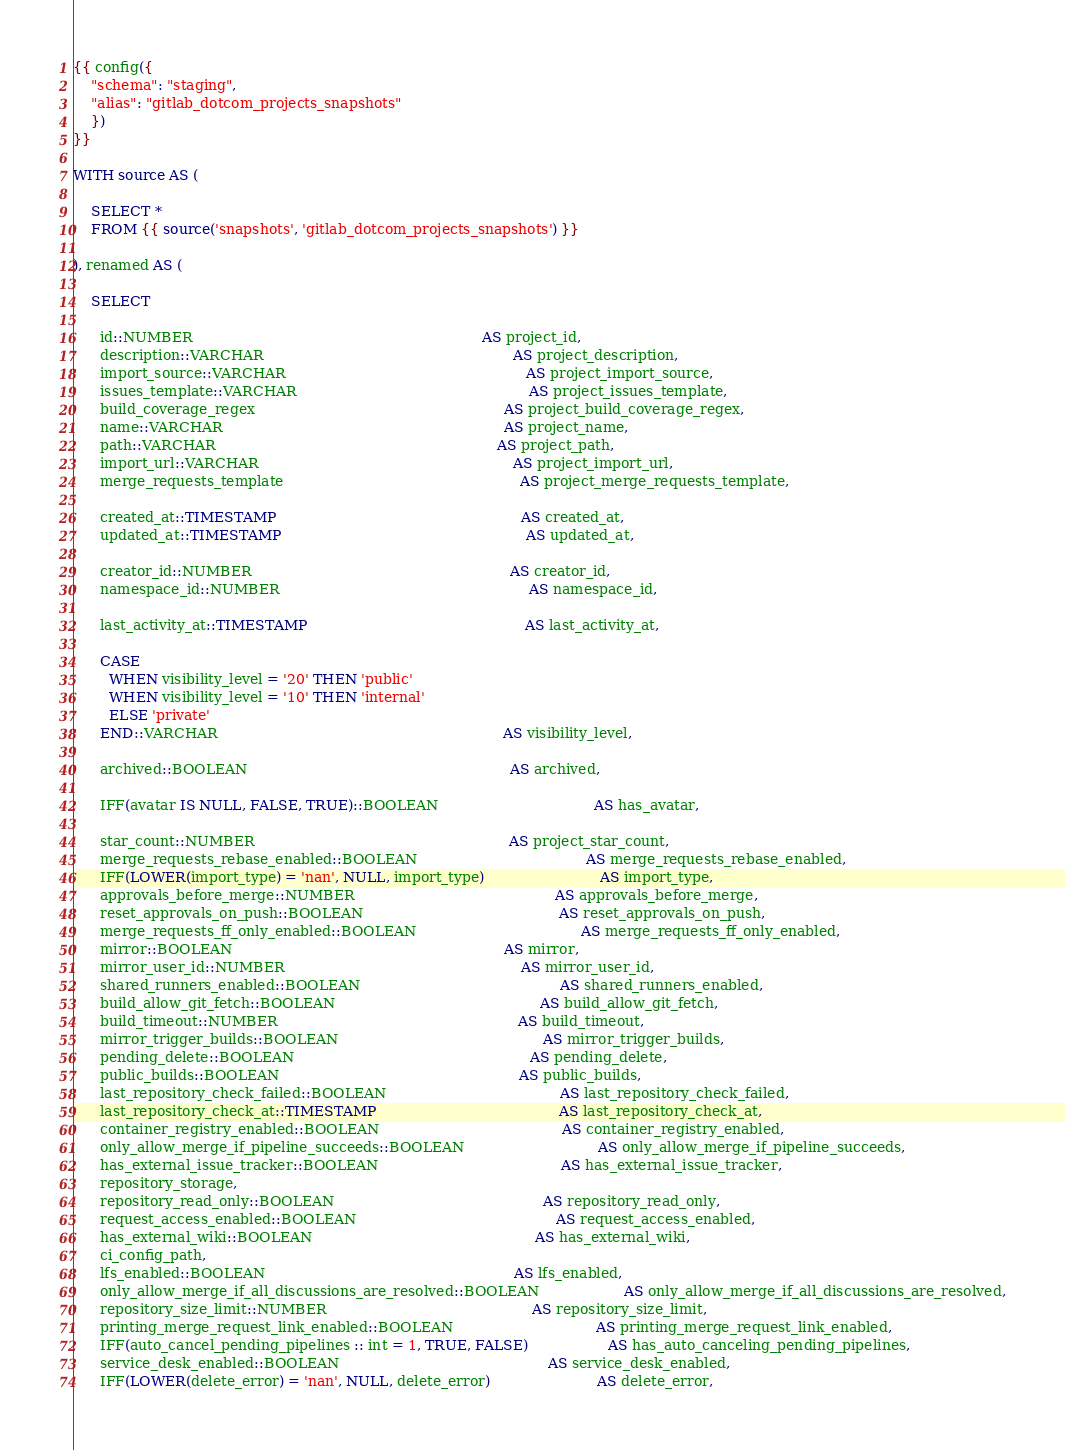Convert code to text. <code><loc_0><loc_0><loc_500><loc_500><_SQL_>{{ config({
    "schema": "staging",
    "alias": "gitlab_dotcom_projects_snapshots"
    })
}}

WITH source AS (

    SELECT *
    FROM {{ source('snapshots', 'gitlab_dotcom_projects_snapshots') }}

), renamed AS (

    SELECT

      id::NUMBER                                                                 AS project_id,
      description::VARCHAR                                                        AS project_description,
      import_source::VARCHAR                                                      AS project_import_source,
      issues_template::VARCHAR                                                    AS project_issues_template,
      build_coverage_regex                                                        AS project_build_coverage_regex,      
      name::VARCHAR                                                               AS project_name,
      path::VARCHAR                                                               AS project_path,
      import_url::VARCHAR                                                         AS project_import_url,
      merge_requests_template                                                     AS project_merge_requests_template,

      created_at::TIMESTAMP                                                       AS created_at,
      updated_at::TIMESTAMP                                                       AS updated_at,

      creator_id::NUMBER                                                          AS creator_id,
      namespace_id::NUMBER                                                        AS namespace_id,

      last_activity_at::TIMESTAMP                                                 AS last_activity_at,

      CASE
        WHEN visibility_level = '20' THEN 'public'
        WHEN visibility_level = '10' THEN 'internal'
        ELSE 'private'
      END::VARCHAR                                                                AS visibility_level,

      archived::BOOLEAN                                                           AS archived,

      IFF(avatar IS NULL, FALSE, TRUE)::BOOLEAN                                   AS has_avatar,

      star_count::NUMBER                                                         AS project_star_count,
      merge_requests_rebase_enabled::BOOLEAN                                      AS merge_requests_rebase_enabled,
      IFF(LOWER(import_type) = 'nan', NULL, import_type)                          AS import_type,
      approvals_before_merge::NUMBER                                             AS approvals_before_merge,
      reset_approvals_on_push::BOOLEAN                                            AS reset_approvals_on_push,
      merge_requests_ff_only_enabled::BOOLEAN                                     AS merge_requests_ff_only_enabled,
      mirror::BOOLEAN                                                             AS mirror,
      mirror_user_id::NUMBER                                                     AS mirror_user_id,
      shared_runners_enabled::BOOLEAN                                             AS shared_runners_enabled,
      build_allow_git_fetch::BOOLEAN                                              AS build_allow_git_fetch,
      build_timeout::NUMBER                                                      AS build_timeout,
      mirror_trigger_builds::BOOLEAN                                              AS mirror_trigger_builds,
      pending_delete::BOOLEAN                                                     AS pending_delete,
      public_builds::BOOLEAN                                                      AS public_builds,
      last_repository_check_failed::BOOLEAN                                       AS last_repository_check_failed,
      last_repository_check_at::TIMESTAMP                                         AS last_repository_check_at,
      container_registry_enabled::BOOLEAN                                         AS container_registry_enabled,
      only_allow_merge_if_pipeline_succeeds::BOOLEAN                              AS only_allow_merge_if_pipeline_succeeds,
      has_external_issue_tracker::BOOLEAN                                         AS has_external_issue_tracker,
      repository_storage,
      repository_read_only::BOOLEAN                                               AS repository_read_only,
      request_access_enabled::BOOLEAN                                             AS request_access_enabled,
      has_external_wiki::BOOLEAN                                                  AS has_external_wiki,
      ci_config_path,
      lfs_enabled::BOOLEAN                                                        AS lfs_enabled,
      only_allow_merge_if_all_discussions_are_resolved::BOOLEAN                   AS only_allow_merge_if_all_discussions_are_resolved,
      repository_size_limit::NUMBER                                              AS repository_size_limit,
      printing_merge_request_link_enabled::BOOLEAN                                AS printing_merge_request_link_enabled,
      IFF(auto_cancel_pending_pipelines :: int = 1, TRUE, FALSE)                  AS has_auto_canceling_pending_pipelines,
      service_desk_enabled::BOOLEAN                                               AS service_desk_enabled,
      IFF(LOWER(delete_error) = 'nan', NULL, delete_error)                        AS delete_error,</code> 